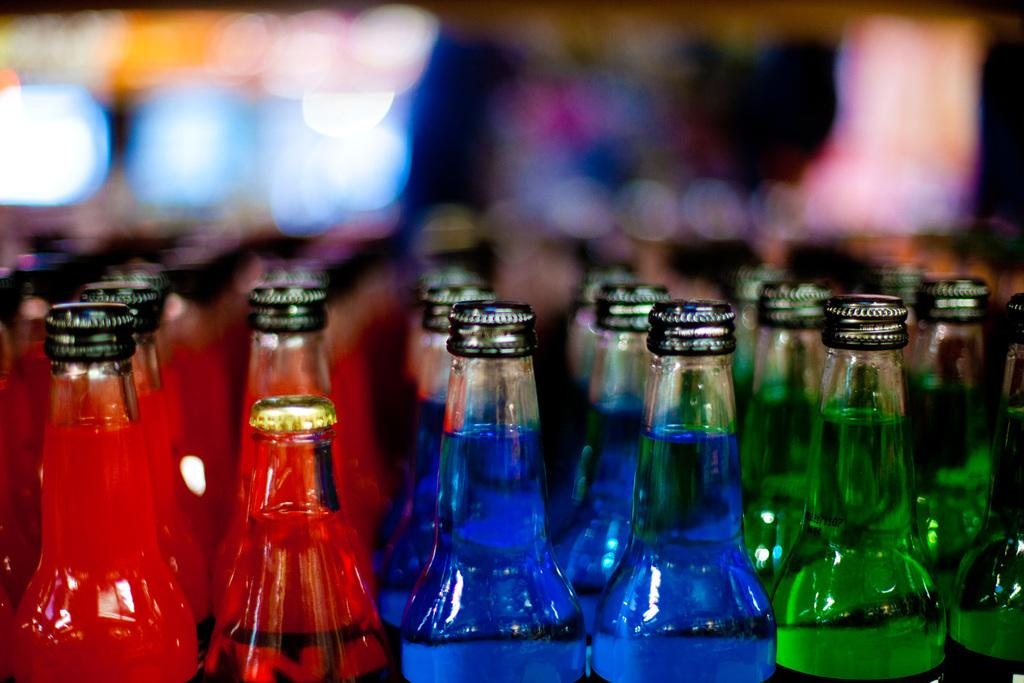What is the main subject of the image? The main subject of the image is a bunch of bottles. What can be found inside the bottles? The bottles contain liquid. How does the mark move around on the bottles in the image? There is no mark present on the bottles in the image. 